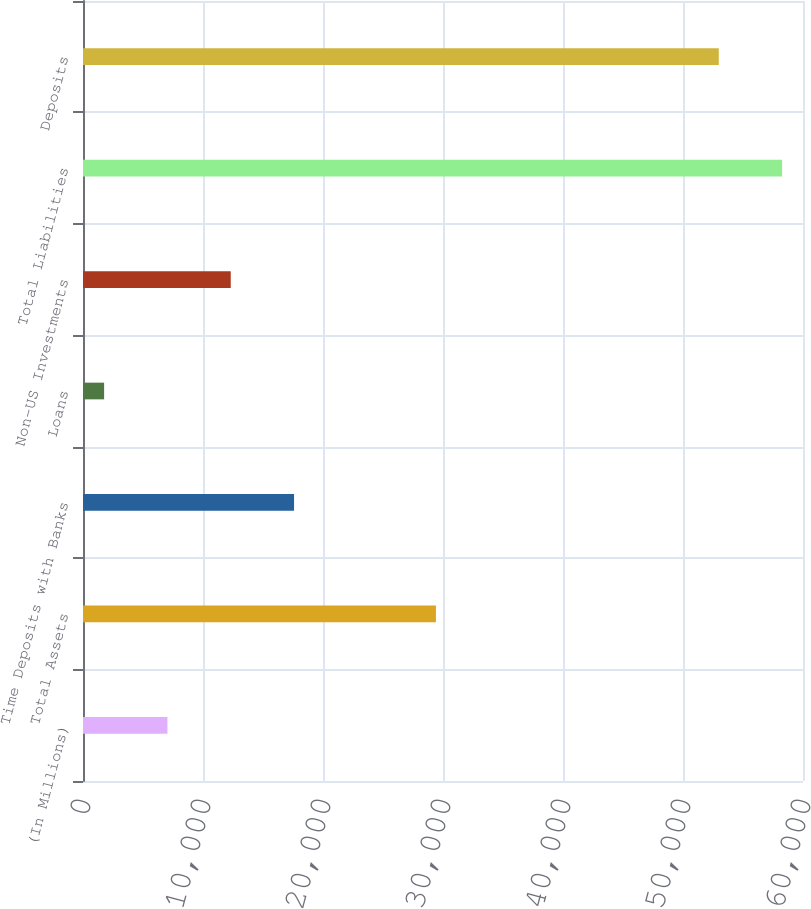Convert chart to OTSL. <chart><loc_0><loc_0><loc_500><loc_500><bar_chart><fcel>(In Millions)<fcel>Total Assets<fcel>Time Deposits with Banks<fcel>Loans<fcel>Non-US Investments<fcel>Total Liabilities<fcel>Deposits<nl><fcel>7035.56<fcel>29411.2<fcel>17587.9<fcel>1759.4<fcel>12311.7<fcel>58257.4<fcel>52981.2<nl></chart> 